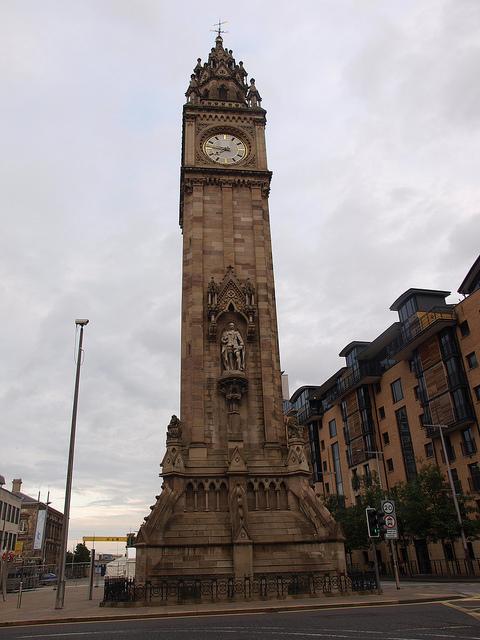What time is it?
Give a very brief answer. 9;45. What time does the clock say?
Concise answer only. 8:40. What are the statues in the background of?
Concise answer only. City. Is it sunny?
Keep it brief. No. Where is the famous landmark in the picture?
Write a very short answer. Big ben. Is the figure in the middle of the clock tower of a human?
Keep it brief. Yes. What color is the sky?
Write a very short answer. Gray. What is the tower made of?
Write a very short answer. Stone. What is on the very top of this building?
Answer briefly. Spire. How tall is the building with the clock?
Keep it brief. 100 feet. 